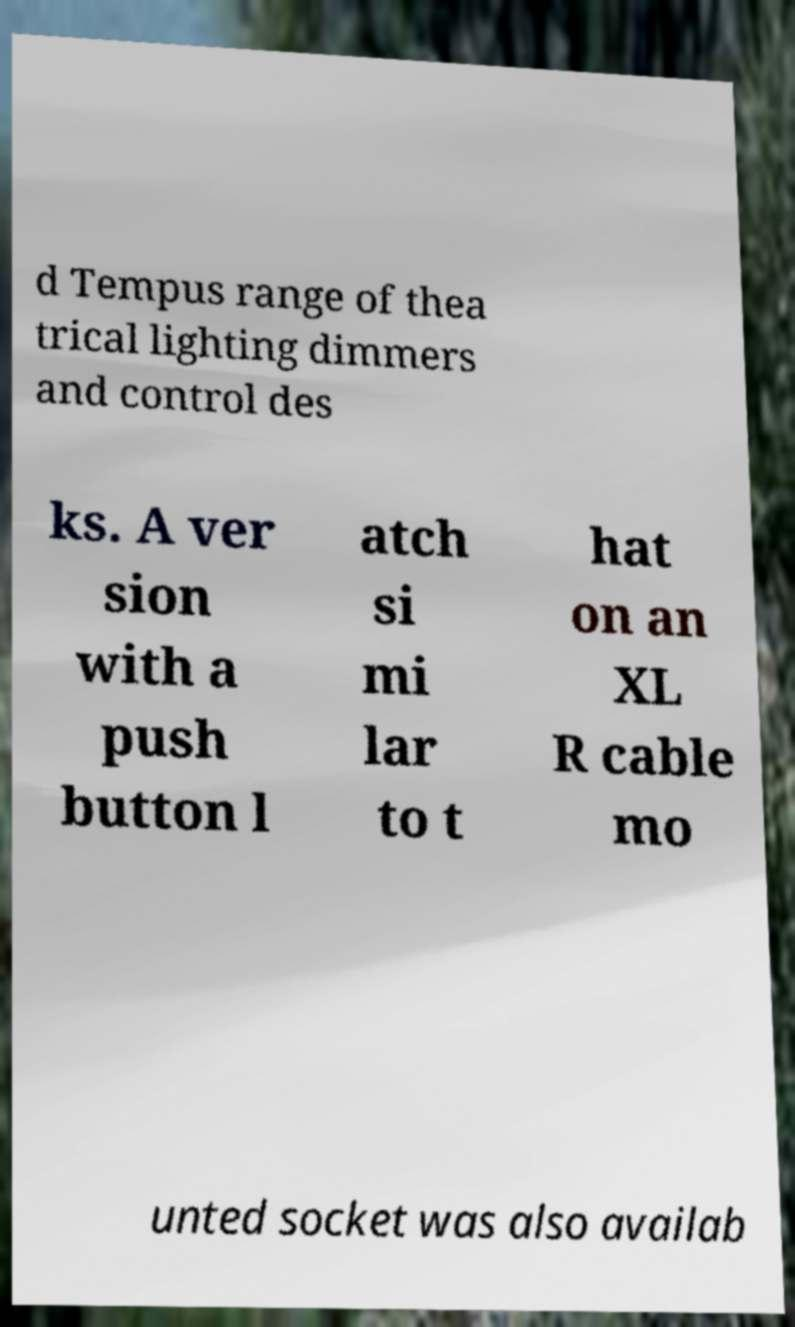There's text embedded in this image that I need extracted. Can you transcribe it verbatim? d Tempus range of thea trical lighting dimmers and control des ks. A ver sion with a push button l atch si mi lar to t hat on an XL R cable mo unted socket was also availab 